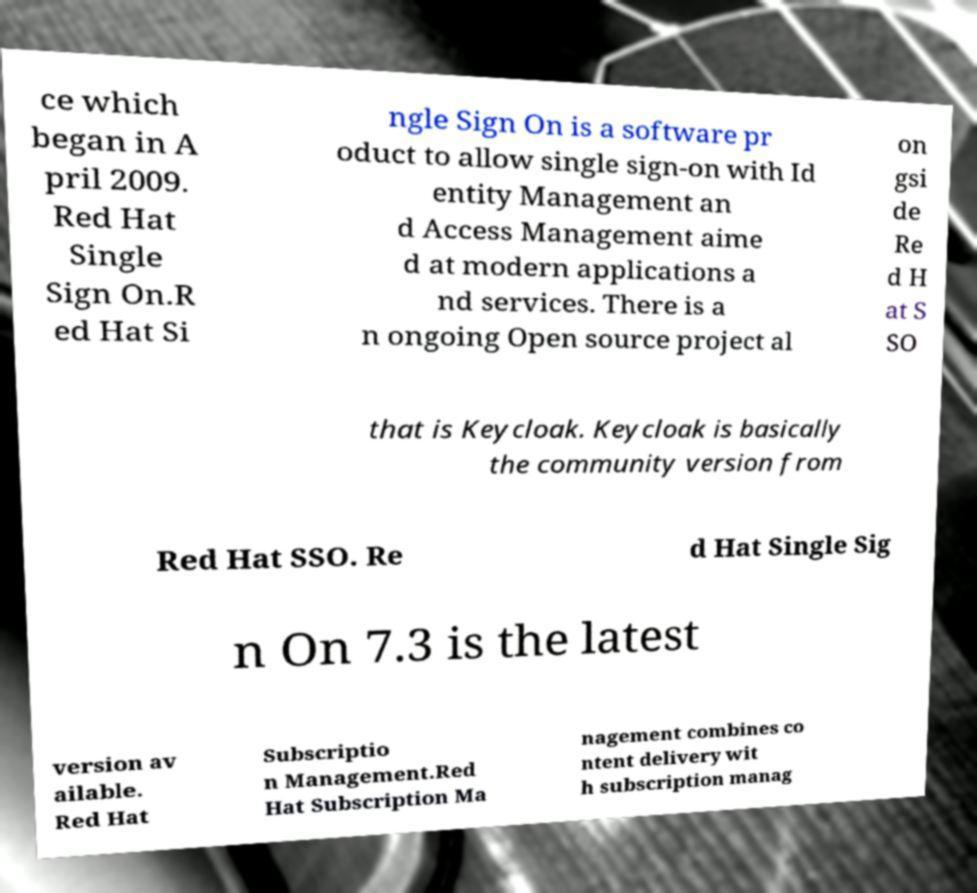Can you accurately transcribe the text from the provided image for me? ce which began in A pril 2009. Red Hat Single Sign On.R ed Hat Si ngle Sign On is a software pr oduct to allow single sign-on with Id entity Management an d Access Management aime d at modern applications a nd services. There is a n ongoing Open source project al on gsi de Re d H at S SO that is Keycloak. Keycloak is basically the community version from Red Hat SSO. Re d Hat Single Sig n On 7.3 is the latest version av ailable. Red Hat Subscriptio n Management.Red Hat Subscription Ma nagement combines co ntent delivery wit h subscription manag 